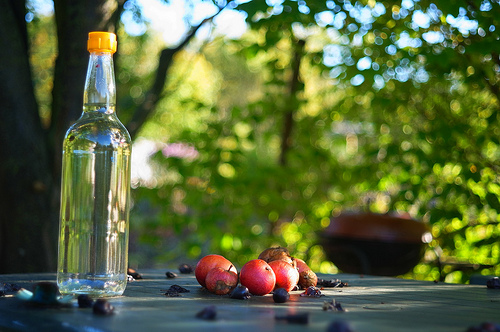What time of day does it seem to be in the image? Based on the quality of the light and the shadows cast, it appears to be late afternoon, which often gives a warm, golden hue to the scenery. Does this light affect the colors in the image? Absolutely, the late afternoon sun bathes the scene in a warm glow that enhances the rich reds and browns of the apples and emphasizes the greens of the background foliage. 